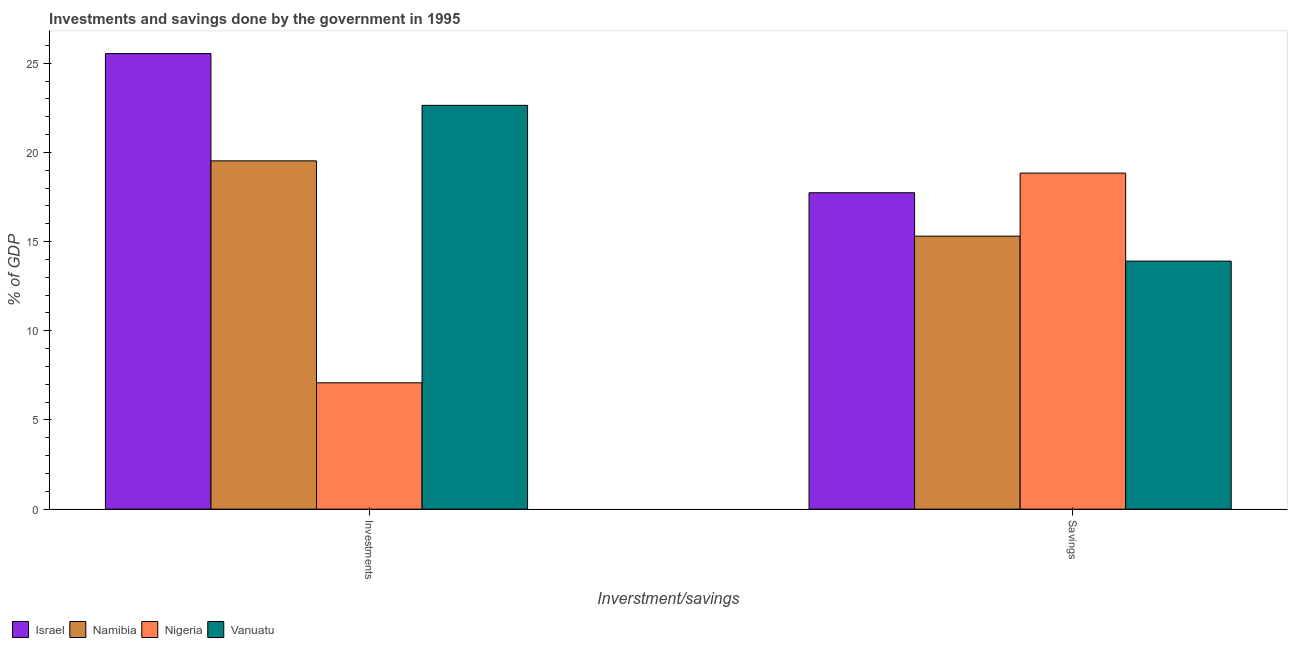How many different coloured bars are there?
Provide a short and direct response. 4. How many groups of bars are there?
Give a very brief answer. 2. Are the number of bars per tick equal to the number of legend labels?
Give a very brief answer. Yes. How many bars are there on the 2nd tick from the right?
Your answer should be compact. 4. What is the label of the 2nd group of bars from the left?
Make the answer very short. Savings. What is the investments of government in Namibia?
Your answer should be very brief. 19.52. Across all countries, what is the maximum investments of government?
Keep it short and to the point. 25.54. Across all countries, what is the minimum investments of government?
Your response must be concise. 7.08. In which country was the savings of government maximum?
Offer a terse response. Nigeria. In which country was the savings of government minimum?
Provide a short and direct response. Vanuatu. What is the total savings of government in the graph?
Keep it short and to the point. 65.78. What is the difference between the savings of government in Israel and that in Nigeria?
Provide a succinct answer. -1.1. What is the difference between the investments of government in Namibia and the savings of government in Vanuatu?
Your response must be concise. 5.62. What is the average investments of government per country?
Provide a short and direct response. 18.7. What is the difference between the investments of government and savings of government in Israel?
Offer a very short reply. 7.8. In how many countries, is the savings of government greater than 23 %?
Ensure brevity in your answer.  0. What is the ratio of the investments of government in Vanuatu to that in Nigeria?
Your answer should be compact. 3.2. Is the savings of government in Nigeria less than that in Israel?
Give a very brief answer. No. What does the 4th bar from the left in Savings represents?
Provide a succinct answer. Vanuatu. What does the 2nd bar from the right in Investments represents?
Ensure brevity in your answer.  Nigeria. How many bars are there?
Your answer should be very brief. 8. Are all the bars in the graph horizontal?
Keep it short and to the point. No. What is the difference between two consecutive major ticks on the Y-axis?
Your answer should be compact. 5. Are the values on the major ticks of Y-axis written in scientific E-notation?
Your answer should be compact. No. Does the graph contain any zero values?
Your answer should be compact. No. How many legend labels are there?
Your answer should be very brief. 4. What is the title of the graph?
Keep it short and to the point. Investments and savings done by the government in 1995. What is the label or title of the X-axis?
Make the answer very short. Inverstment/savings. What is the label or title of the Y-axis?
Make the answer very short. % of GDP. What is the % of GDP of Israel in Investments?
Offer a very short reply. 25.54. What is the % of GDP in Namibia in Investments?
Make the answer very short. 19.52. What is the % of GDP of Nigeria in Investments?
Give a very brief answer. 7.08. What is the % of GDP of Vanuatu in Investments?
Provide a short and direct response. 22.64. What is the % of GDP in Israel in Savings?
Make the answer very short. 17.74. What is the % of GDP of Namibia in Savings?
Give a very brief answer. 15.3. What is the % of GDP in Nigeria in Savings?
Your answer should be compact. 18.84. What is the % of GDP of Vanuatu in Savings?
Offer a very short reply. 13.9. Across all Inverstment/savings, what is the maximum % of GDP of Israel?
Ensure brevity in your answer.  25.54. Across all Inverstment/savings, what is the maximum % of GDP in Namibia?
Provide a short and direct response. 19.52. Across all Inverstment/savings, what is the maximum % of GDP in Nigeria?
Ensure brevity in your answer.  18.84. Across all Inverstment/savings, what is the maximum % of GDP in Vanuatu?
Your answer should be very brief. 22.64. Across all Inverstment/savings, what is the minimum % of GDP of Israel?
Your response must be concise. 17.74. Across all Inverstment/savings, what is the minimum % of GDP of Namibia?
Ensure brevity in your answer.  15.3. Across all Inverstment/savings, what is the minimum % of GDP in Nigeria?
Your answer should be compact. 7.08. Across all Inverstment/savings, what is the minimum % of GDP of Vanuatu?
Your answer should be very brief. 13.9. What is the total % of GDP of Israel in the graph?
Your response must be concise. 43.28. What is the total % of GDP of Namibia in the graph?
Your response must be concise. 34.83. What is the total % of GDP in Nigeria in the graph?
Ensure brevity in your answer.  25.92. What is the total % of GDP in Vanuatu in the graph?
Provide a succinct answer. 36.54. What is the difference between the % of GDP of Israel in Investments and that in Savings?
Provide a succinct answer. 7.8. What is the difference between the % of GDP of Namibia in Investments and that in Savings?
Provide a succinct answer. 4.22. What is the difference between the % of GDP of Nigeria in Investments and that in Savings?
Your response must be concise. -11.76. What is the difference between the % of GDP in Vanuatu in Investments and that in Savings?
Offer a very short reply. 8.73. What is the difference between the % of GDP in Israel in Investments and the % of GDP in Namibia in Savings?
Keep it short and to the point. 10.23. What is the difference between the % of GDP of Israel in Investments and the % of GDP of Nigeria in Savings?
Provide a succinct answer. 6.7. What is the difference between the % of GDP of Israel in Investments and the % of GDP of Vanuatu in Savings?
Your answer should be very brief. 11.63. What is the difference between the % of GDP in Namibia in Investments and the % of GDP in Nigeria in Savings?
Give a very brief answer. 0.69. What is the difference between the % of GDP in Namibia in Investments and the % of GDP in Vanuatu in Savings?
Make the answer very short. 5.62. What is the difference between the % of GDP in Nigeria in Investments and the % of GDP in Vanuatu in Savings?
Your answer should be compact. -6.82. What is the average % of GDP of Israel per Inverstment/savings?
Your answer should be compact. 21.64. What is the average % of GDP in Namibia per Inverstment/savings?
Ensure brevity in your answer.  17.41. What is the average % of GDP of Nigeria per Inverstment/savings?
Your answer should be compact. 12.96. What is the average % of GDP in Vanuatu per Inverstment/savings?
Make the answer very short. 18.27. What is the difference between the % of GDP of Israel and % of GDP of Namibia in Investments?
Offer a terse response. 6.01. What is the difference between the % of GDP in Israel and % of GDP in Nigeria in Investments?
Your response must be concise. 18.45. What is the difference between the % of GDP in Israel and % of GDP in Vanuatu in Investments?
Your response must be concise. 2.9. What is the difference between the % of GDP in Namibia and % of GDP in Nigeria in Investments?
Give a very brief answer. 12.44. What is the difference between the % of GDP in Namibia and % of GDP in Vanuatu in Investments?
Your response must be concise. -3.11. What is the difference between the % of GDP in Nigeria and % of GDP in Vanuatu in Investments?
Keep it short and to the point. -15.55. What is the difference between the % of GDP of Israel and % of GDP of Namibia in Savings?
Your answer should be very brief. 2.44. What is the difference between the % of GDP of Israel and % of GDP of Nigeria in Savings?
Your answer should be very brief. -1.1. What is the difference between the % of GDP in Israel and % of GDP in Vanuatu in Savings?
Ensure brevity in your answer.  3.83. What is the difference between the % of GDP in Namibia and % of GDP in Nigeria in Savings?
Offer a very short reply. -3.54. What is the difference between the % of GDP of Namibia and % of GDP of Vanuatu in Savings?
Give a very brief answer. 1.4. What is the difference between the % of GDP in Nigeria and % of GDP in Vanuatu in Savings?
Provide a short and direct response. 4.93. What is the ratio of the % of GDP of Israel in Investments to that in Savings?
Provide a short and direct response. 1.44. What is the ratio of the % of GDP of Namibia in Investments to that in Savings?
Your answer should be compact. 1.28. What is the ratio of the % of GDP in Nigeria in Investments to that in Savings?
Keep it short and to the point. 0.38. What is the ratio of the % of GDP in Vanuatu in Investments to that in Savings?
Your answer should be very brief. 1.63. What is the difference between the highest and the second highest % of GDP of Israel?
Ensure brevity in your answer.  7.8. What is the difference between the highest and the second highest % of GDP of Namibia?
Ensure brevity in your answer.  4.22. What is the difference between the highest and the second highest % of GDP of Nigeria?
Make the answer very short. 11.76. What is the difference between the highest and the second highest % of GDP in Vanuatu?
Your response must be concise. 8.73. What is the difference between the highest and the lowest % of GDP in Israel?
Ensure brevity in your answer.  7.8. What is the difference between the highest and the lowest % of GDP of Namibia?
Your response must be concise. 4.22. What is the difference between the highest and the lowest % of GDP in Nigeria?
Provide a short and direct response. 11.76. What is the difference between the highest and the lowest % of GDP in Vanuatu?
Your answer should be very brief. 8.73. 